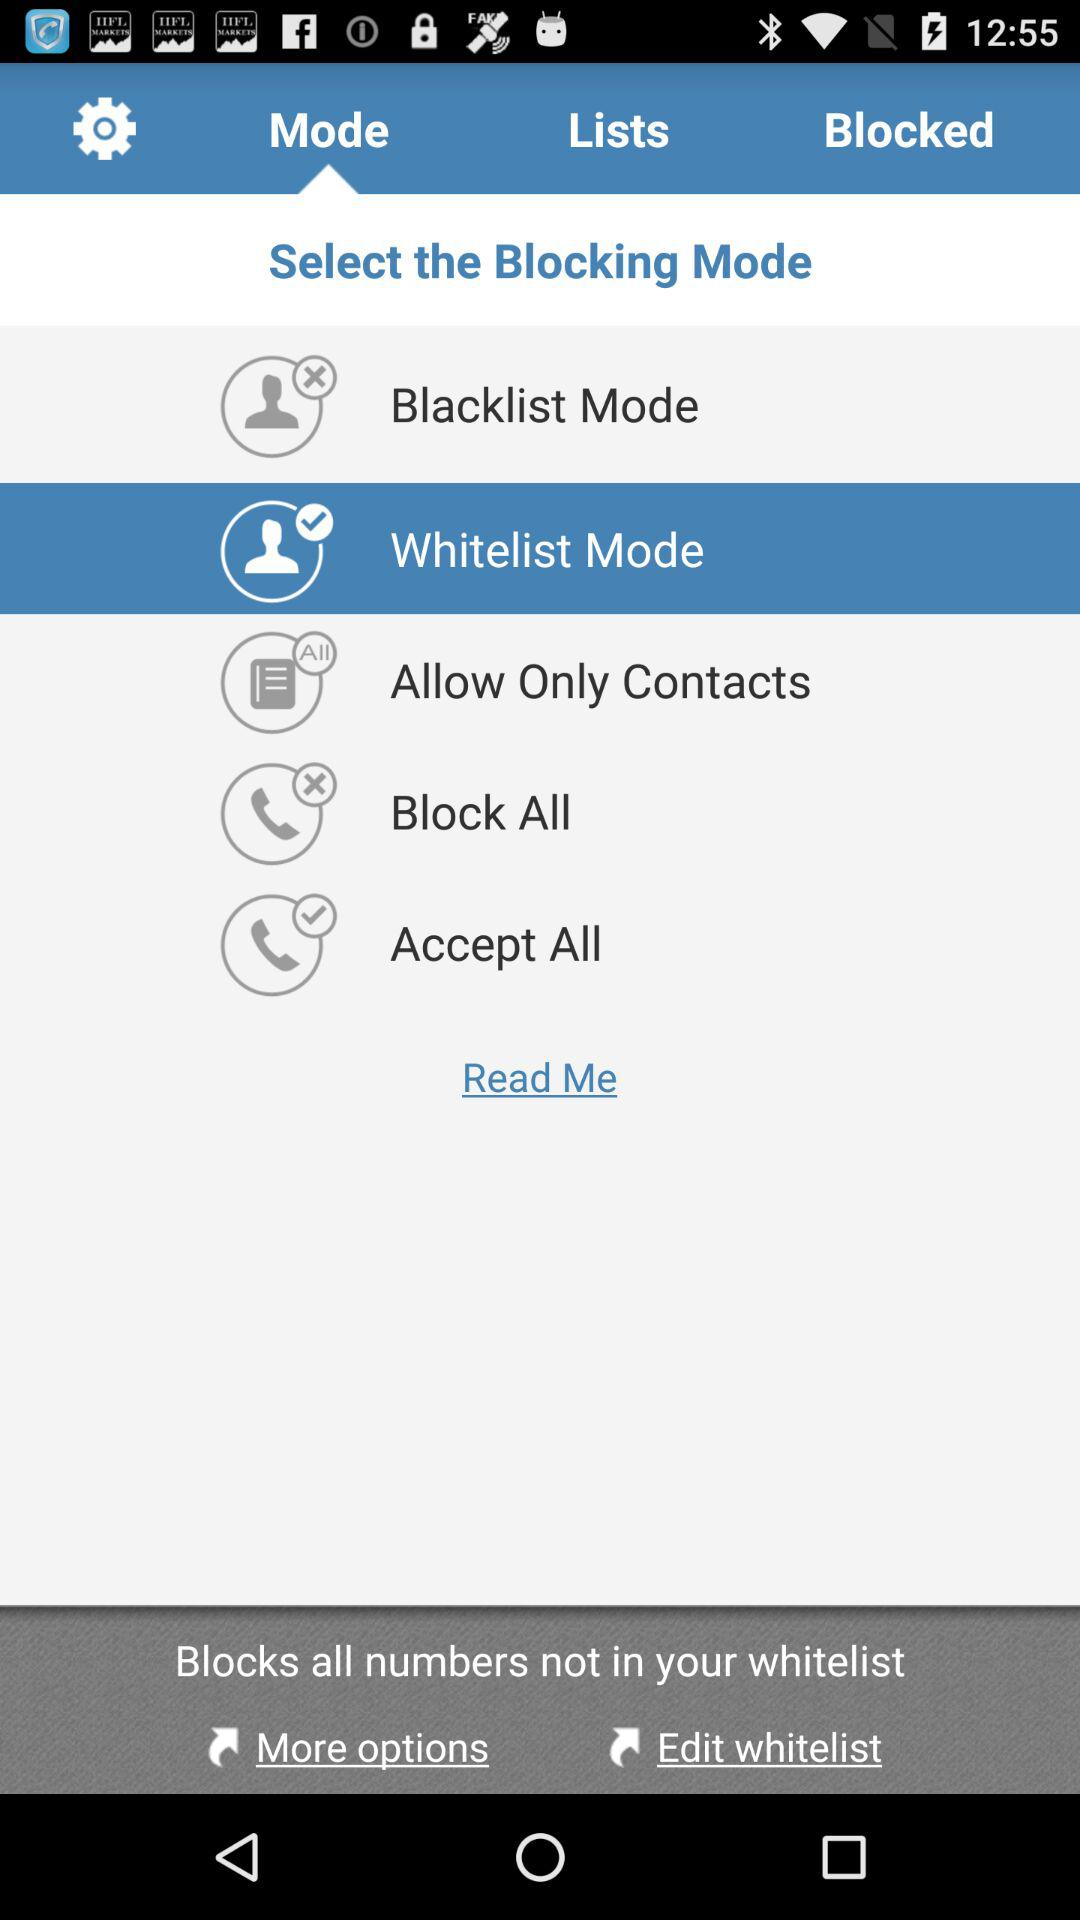Which blocking mode is selected? The selected blocking mode is "Whitelist Mode". 